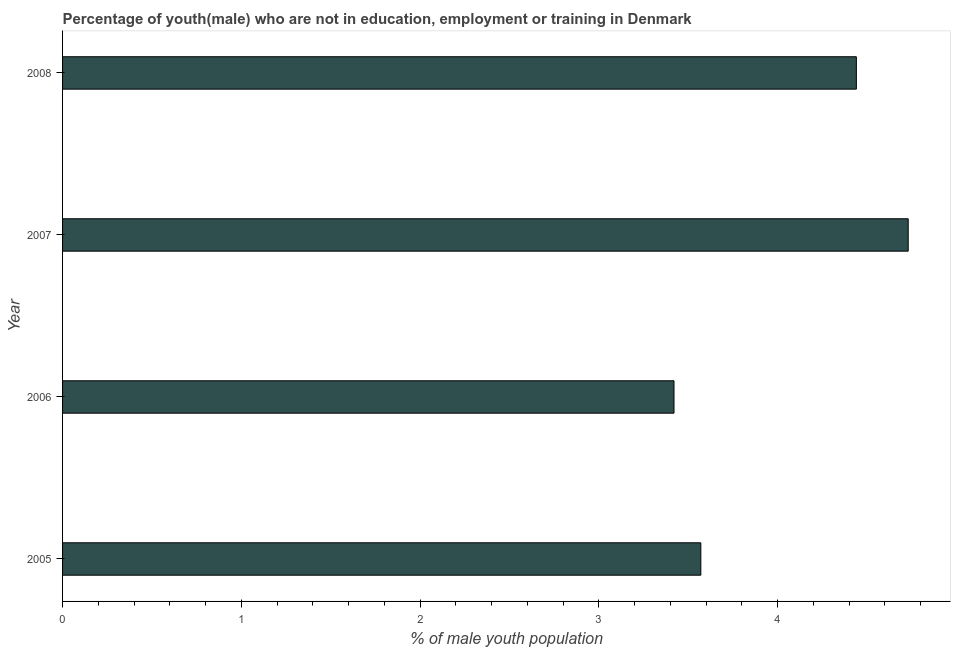Does the graph contain any zero values?
Provide a short and direct response. No. Does the graph contain grids?
Your answer should be compact. No. What is the title of the graph?
Your answer should be very brief. Percentage of youth(male) who are not in education, employment or training in Denmark. What is the label or title of the X-axis?
Provide a succinct answer. % of male youth population. What is the label or title of the Y-axis?
Your answer should be very brief. Year. What is the unemployed male youth population in 2006?
Your answer should be compact. 3.42. Across all years, what is the maximum unemployed male youth population?
Offer a terse response. 4.73. Across all years, what is the minimum unemployed male youth population?
Ensure brevity in your answer.  3.42. What is the sum of the unemployed male youth population?
Keep it short and to the point. 16.16. What is the difference between the unemployed male youth population in 2006 and 2007?
Give a very brief answer. -1.31. What is the average unemployed male youth population per year?
Keep it short and to the point. 4.04. What is the median unemployed male youth population?
Provide a short and direct response. 4. In how many years, is the unemployed male youth population greater than 0.6 %?
Ensure brevity in your answer.  4. What is the ratio of the unemployed male youth population in 2006 to that in 2008?
Your answer should be compact. 0.77. What is the difference between the highest and the second highest unemployed male youth population?
Provide a succinct answer. 0.29. Is the sum of the unemployed male youth population in 2007 and 2008 greater than the maximum unemployed male youth population across all years?
Offer a very short reply. Yes. What is the difference between the highest and the lowest unemployed male youth population?
Make the answer very short. 1.31. In how many years, is the unemployed male youth population greater than the average unemployed male youth population taken over all years?
Your response must be concise. 2. How many bars are there?
Provide a short and direct response. 4. Are all the bars in the graph horizontal?
Provide a succinct answer. Yes. How many years are there in the graph?
Keep it short and to the point. 4. Are the values on the major ticks of X-axis written in scientific E-notation?
Offer a very short reply. No. What is the % of male youth population in 2005?
Offer a terse response. 3.57. What is the % of male youth population of 2006?
Offer a terse response. 3.42. What is the % of male youth population of 2007?
Provide a succinct answer. 4.73. What is the % of male youth population of 2008?
Ensure brevity in your answer.  4.44. What is the difference between the % of male youth population in 2005 and 2006?
Provide a short and direct response. 0.15. What is the difference between the % of male youth population in 2005 and 2007?
Your answer should be very brief. -1.16. What is the difference between the % of male youth population in 2005 and 2008?
Ensure brevity in your answer.  -0.87. What is the difference between the % of male youth population in 2006 and 2007?
Your response must be concise. -1.31. What is the difference between the % of male youth population in 2006 and 2008?
Give a very brief answer. -1.02. What is the difference between the % of male youth population in 2007 and 2008?
Your answer should be very brief. 0.29. What is the ratio of the % of male youth population in 2005 to that in 2006?
Keep it short and to the point. 1.04. What is the ratio of the % of male youth population in 2005 to that in 2007?
Your answer should be very brief. 0.76. What is the ratio of the % of male youth population in 2005 to that in 2008?
Your answer should be compact. 0.8. What is the ratio of the % of male youth population in 2006 to that in 2007?
Offer a terse response. 0.72. What is the ratio of the % of male youth population in 2006 to that in 2008?
Your answer should be very brief. 0.77. What is the ratio of the % of male youth population in 2007 to that in 2008?
Your answer should be compact. 1.06. 